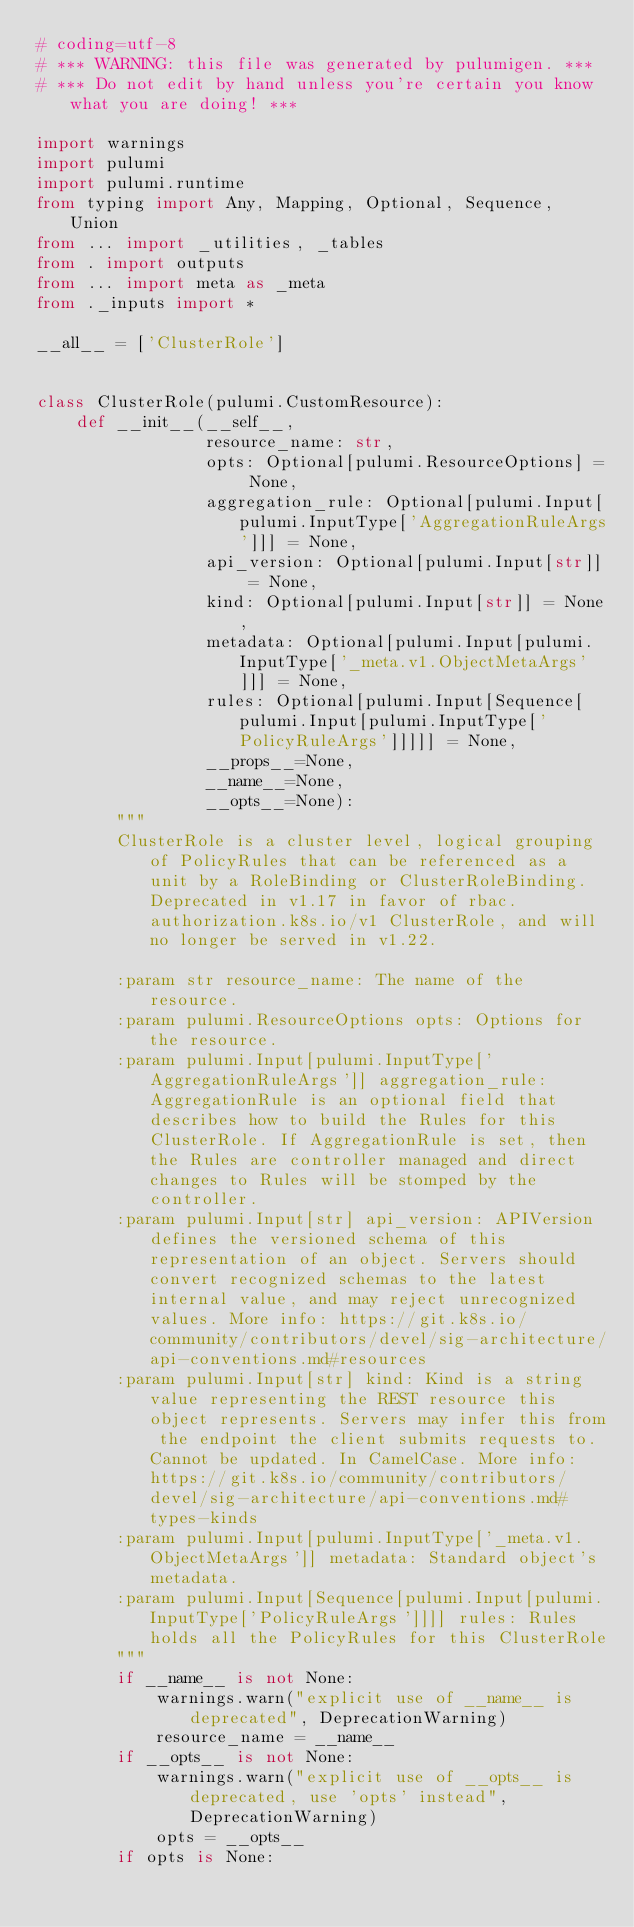<code> <loc_0><loc_0><loc_500><loc_500><_Python_># coding=utf-8
# *** WARNING: this file was generated by pulumigen. ***
# *** Do not edit by hand unless you're certain you know what you are doing! ***

import warnings
import pulumi
import pulumi.runtime
from typing import Any, Mapping, Optional, Sequence, Union
from ... import _utilities, _tables
from . import outputs
from ... import meta as _meta
from ._inputs import *

__all__ = ['ClusterRole']


class ClusterRole(pulumi.CustomResource):
    def __init__(__self__,
                 resource_name: str,
                 opts: Optional[pulumi.ResourceOptions] = None,
                 aggregation_rule: Optional[pulumi.Input[pulumi.InputType['AggregationRuleArgs']]] = None,
                 api_version: Optional[pulumi.Input[str]] = None,
                 kind: Optional[pulumi.Input[str]] = None,
                 metadata: Optional[pulumi.Input[pulumi.InputType['_meta.v1.ObjectMetaArgs']]] = None,
                 rules: Optional[pulumi.Input[Sequence[pulumi.Input[pulumi.InputType['PolicyRuleArgs']]]]] = None,
                 __props__=None,
                 __name__=None,
                 __opts__=None):
        """
        ClusterRole is a cluster level, logical grouping of PolicyRules that can be referenced as a unit by a RoleBinding or ClusterRoleBinding. Deprecated in v1.17 in favor of rbac.authorization.k8s.io/v1 ClusterRole, and will no longer be served in v1.22.

        :param str resource_name: The name of the resource.
        :param pulumi.ResourceOptions opts: Options for the resource.
        :param pulumi.Input[pulumi.InputType['AggregationRuleArgs']] aggregation_rule: AggregationRule is an optional field that describes how to build the Rules for this ClusterRole. If AggregationRule is set, then the Rules are controller managed and direct changes to Rules will be stomped by the controller.
        :param pulumi.Input[str] api_version: APIVersion defines the versioned schema of this representation of an object. Servers should convert recognized schemas to the latest internal value, and may reject unrecognized values. More info: https://git.k8s.io/community/contributors/devel/sig-architecture/api-conventions.md#resources
        :param pulumi.Input[str] kind: Kind is a string value representing the REST resource this object represents. Servers may infer this from the endpoint the client submits requests to. Cannot be updated. In CamelCase. More info: https://git.k8s.io/community/contributors/devel/sig-architecture/api-conventions.md#types-kinds
        :param pulumi.Input[pulumi.InputType['_meta.v1.ObjectMetaArgs']] metadata: Standard object's metadata.
        :param pulumi.Input[Sequence[pulumi.Input[pulumi.InputType['PolicyRuleArgs']]]] rules: Rules holds all the PolicyRules for this ClusterRole
        """
        if __name__ is not None:
            warnings.warn("explicit use of __name__ is deprecated", DeprecationWarning)
            resource_name = __name__
        if __opts__ is not None:
            warnings.warn("explicit use of __opts__ is deprecated, use 'opts' instead", DeprecationWarning)
            opts = __opts__
        if opts is None:</code> 